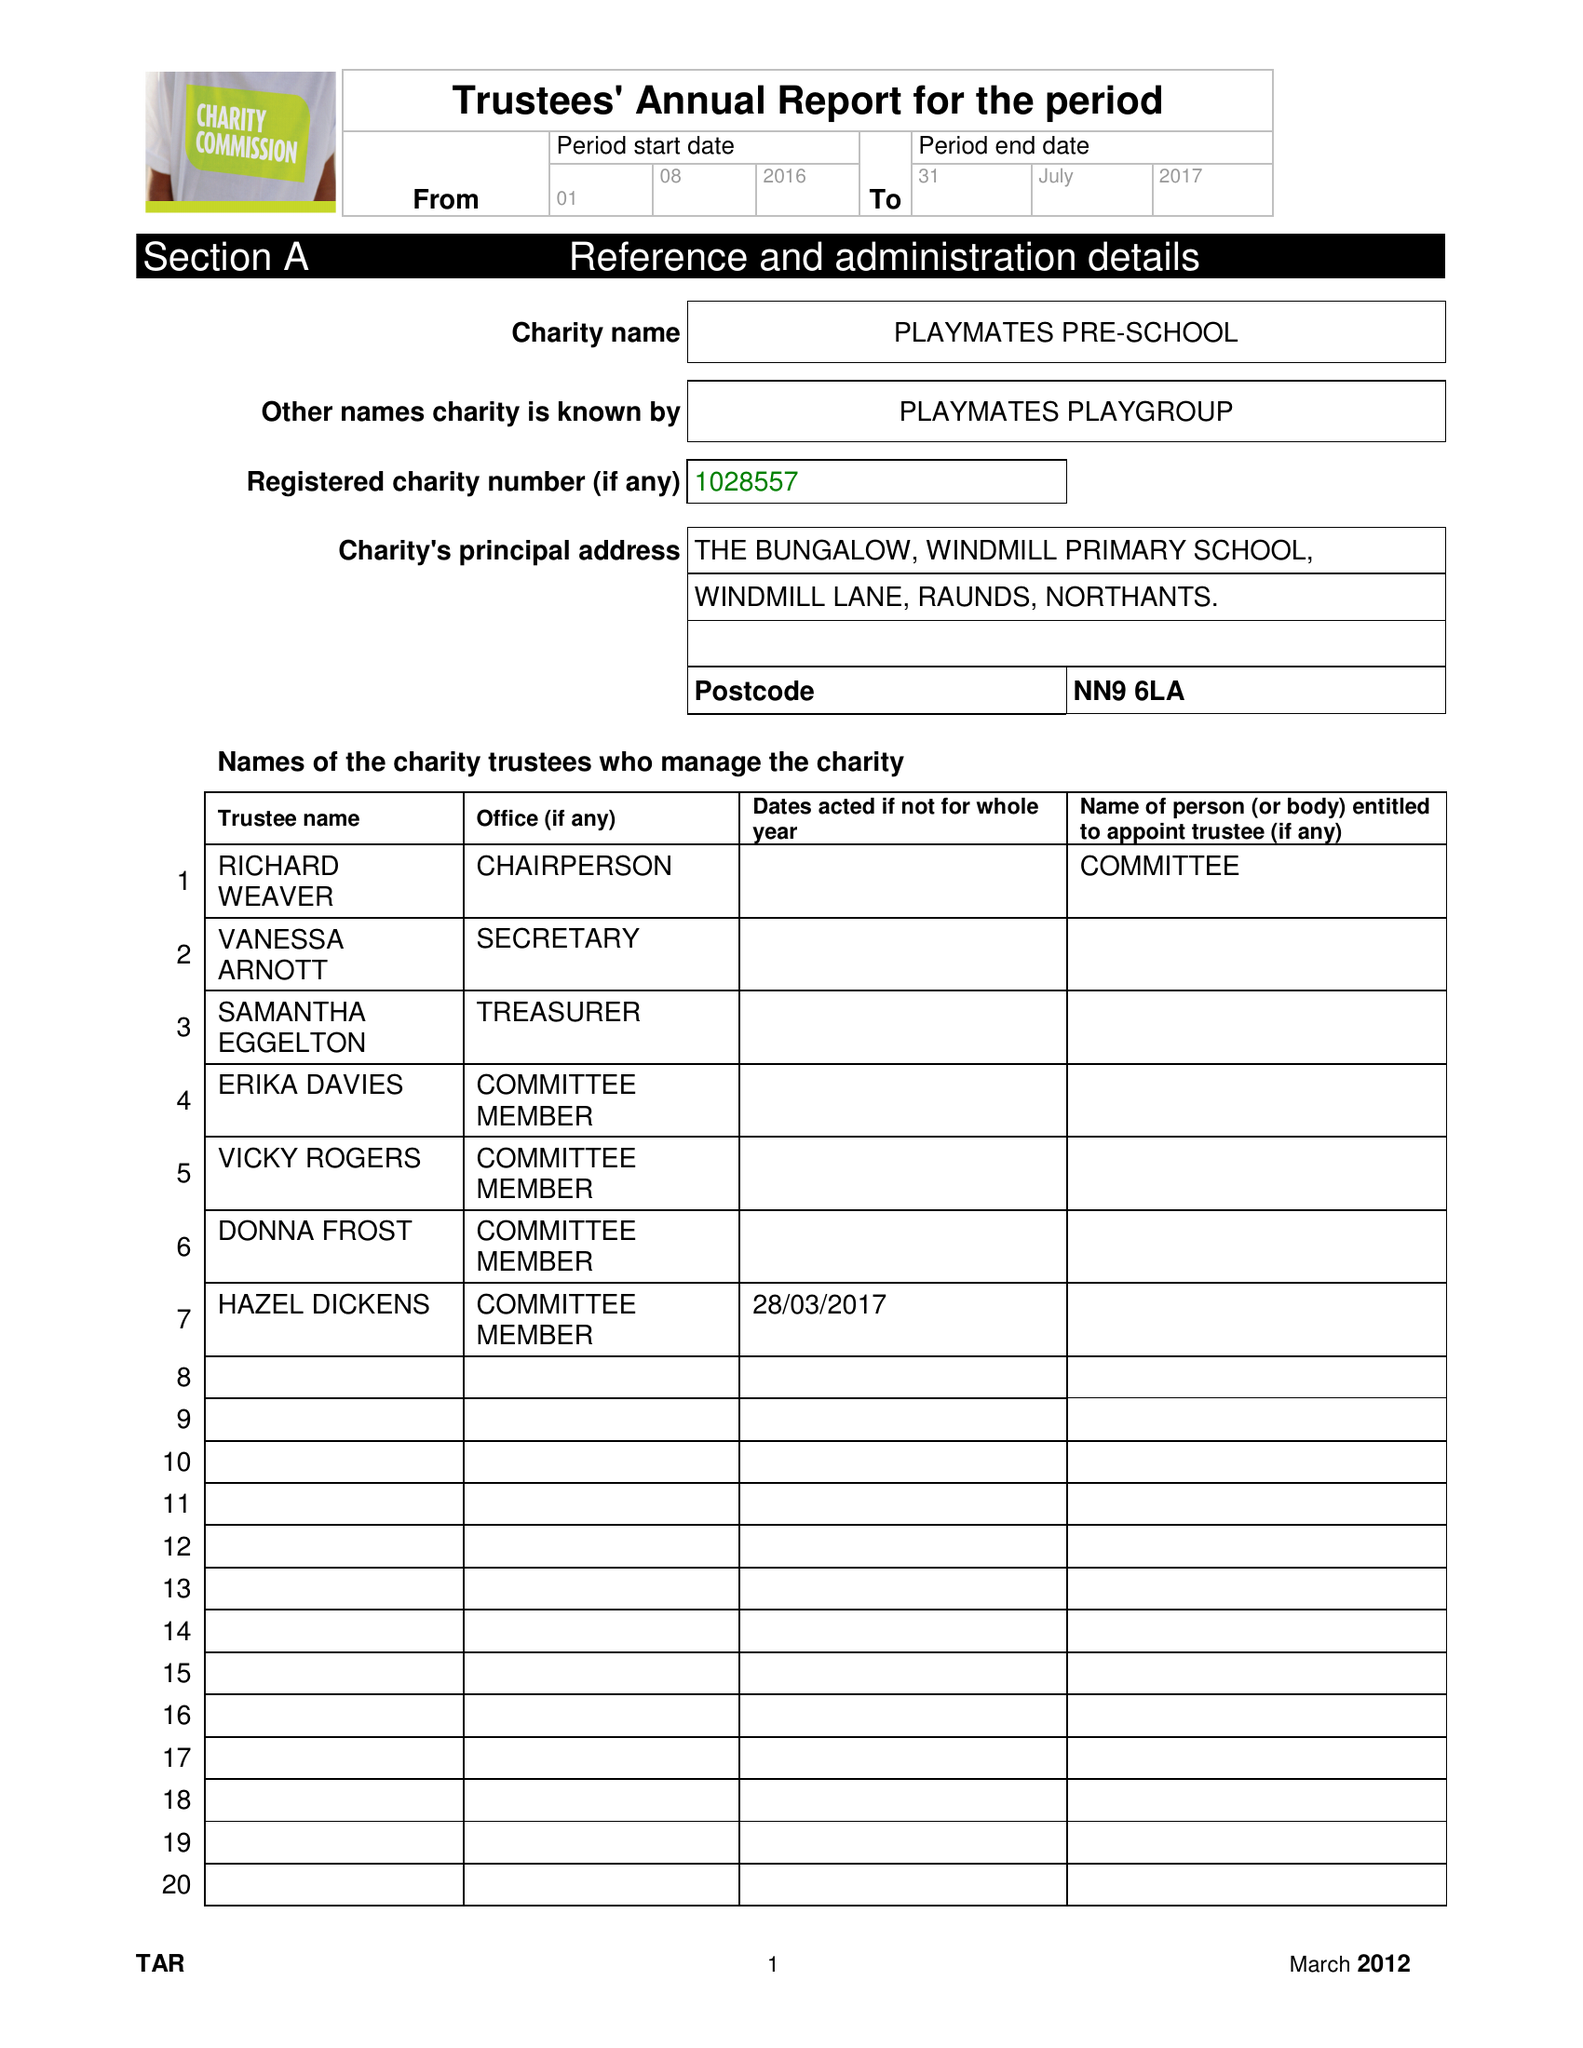What is the value for the address__post_town?
Answer the question using a single word or phrase. WELLINGBOROUGH 